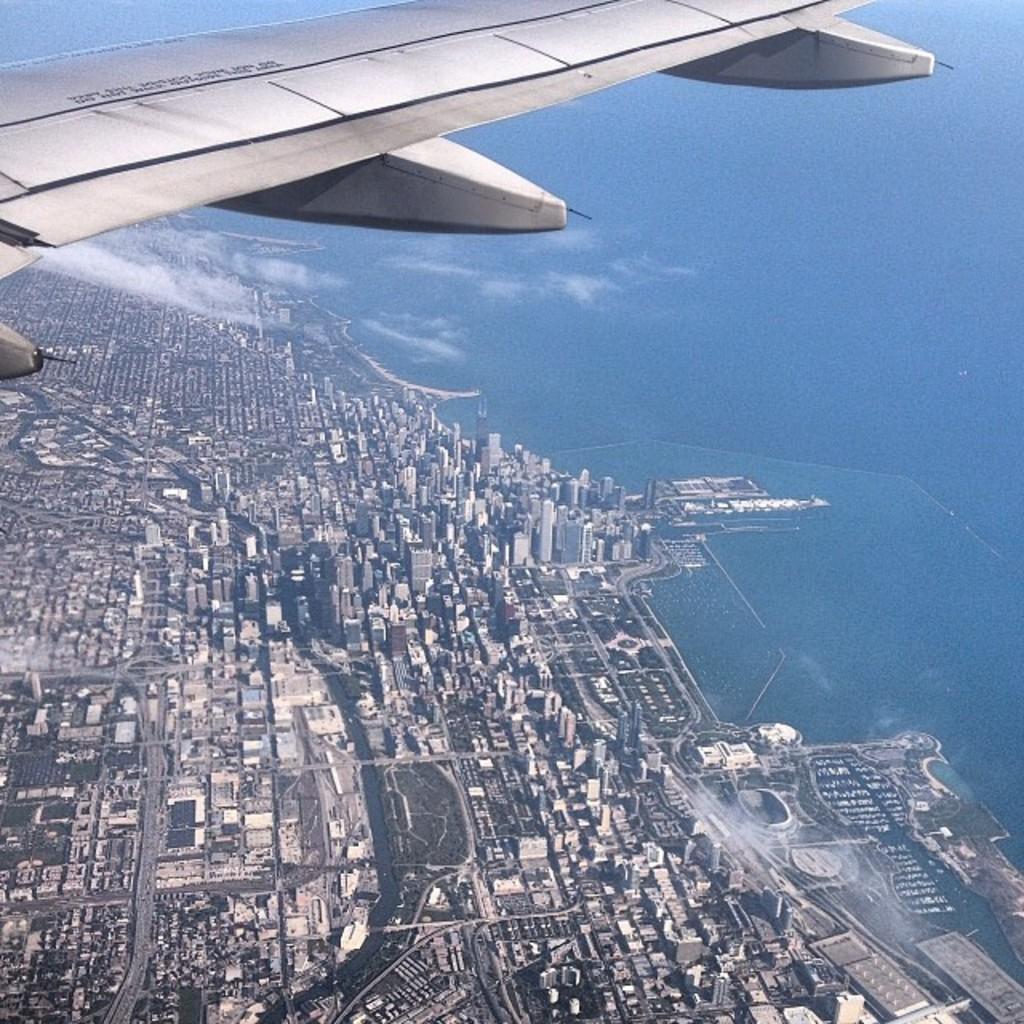Describe this image in one or two sentences. In this image we can see there is an airplane in the sky and at the bottom there are buildings. 